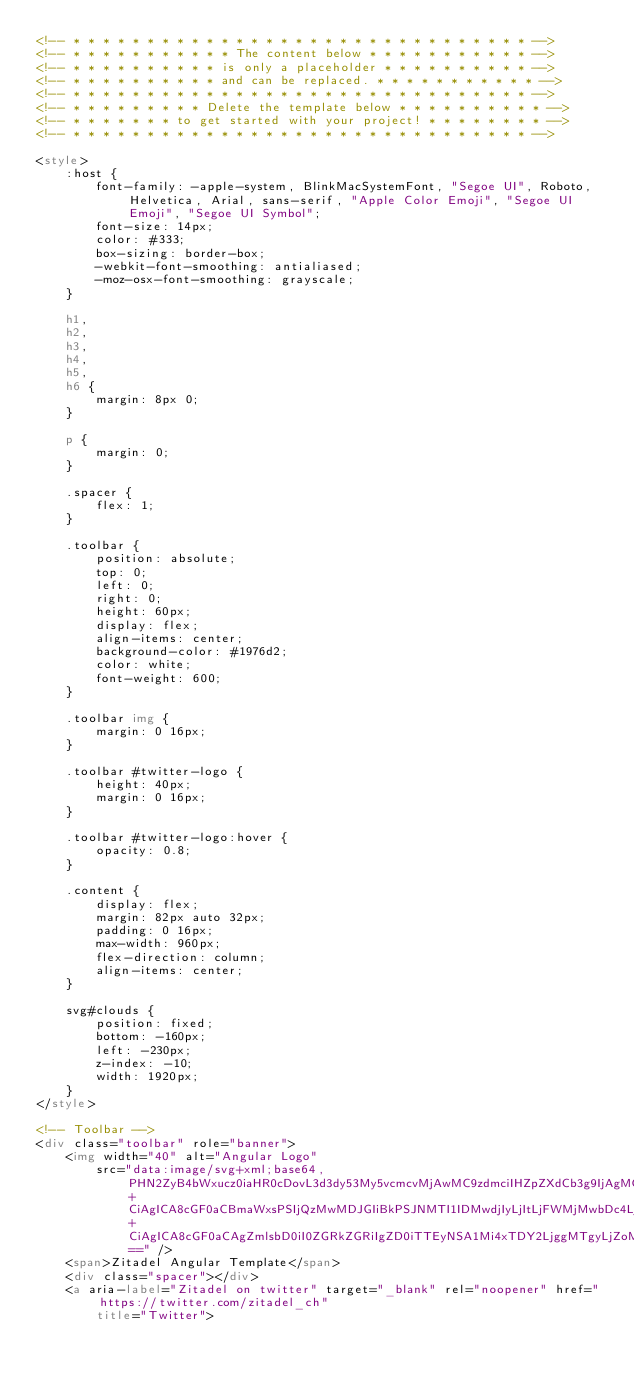<code> <loc_0><loc_0><loc_500><loc_500><_HTML_><!-- * * * * * * * * * * * * * * * * * * * * * * * * * * * * * * * -->
<!-- * * * * * * * * * * * The content below * * * * * * * * * * * -->
<!-- * * * * * * * * * * is only a placeholder * * * * * * * * * * -->
<!-- * * * * * * * * * * and can be replaced. * * * * * * * * * * * -->
<!-- * * * * * * * * * * * * * * * * * * * * * * * * * * * * * * * -->
<!-- * * * * * * * * * Delete the template below * * * * * * * * * * -->
<!-- * * * * * * * to get started with your project! * * * * * * * * -->
<!-- * * * * * * * * * * * * * * * * * * * * * * * * * * * * * * * -->

<style>
    :host {
        font-family: -apple-system, BlinkMacSystemFont, "Segoe UI", Roboto, Helvetica, Arial, sans-serif, "Apple Color Emoji", "Segoe UI Emoji", "Segoe UI Symbol";
        font-size: 14px;
        color: #333;
        box-sizing: border-box;
        -webkit-font-smoothing: antialiased;
        -moz-osx-font-smoothing: grayscale;
    }

    h1,
    h2,
    h3,
    h4,
    h5,
    h6 {
        margin: 8px 0;
    }

    p {
        margin: 0;
    }

    .spacer {
        flex: 1;
    }

    .toolbar {
        position: absolute;
        top: 0;
        left: 0;
        right: 0;
        height: 60px;
        display: flex;
        align-items: center;
        background-color: #1976d2;
        color: white;
        font-weight: 600;
    }

    .toolbar img {
        margin: 0 16px;
    }

    .toolbar #twitter-logo {
        height: 40px;
        margin: 0 16px;
    }

    .toolbar #twitter-logo:hover {
        opacity: 0.8;
    }

    .content {
        display: flex;
        margin: 82px auto 32px;
        padding: 0 16px;
        max-width: 960px;
        flex-direction: column;
        align-items: center;
    }

    svg#clouds {
        position: fixed;
        bottom: -160px;
        left: -230px;
        z-index: -10;
        width: 1920px;
    }
</style>

<!-- Toolbar -->
<div class="toolbar" role="banner">
    <img width="40" alt="Angular Logo"
        src="data:image/svg+xml;base64,PHN2ZyB4bWxucz0iaHR0cDovL3d3dy53My5vcmcvMjAwMC9zdmciIHZpZXdCb3g9IjAgMCAyNTAgMjUwIj4KICAgIDxwYXRoIGZpbGw9IiNERDAwMzEiIGQ9Ik0xMjUgMzBMMzEuOSA2My4ybDE0LjIgMTIzLjFMMTI1IDIzMGw3OC45LTQzLjcgMTQuMi0xMjMuMXoiIC8+CiAgICA8cGF0aCBmaWxsPSIjQzMwMDJGIiBkPSJNMTI1IDMwdjIyLjItLjFWMjMwbDc4LjktNDMuNyAxNC4yLTEyMy4xTDEyNSAzMHoiIC8+CiAgICA8cGF0aCAgZmlsbD0iI0ZGRkZGRiIgZD0iTTEyNSA1Mi4xTDY2LjggMTgyLjZoMjEuN2wxMS43LTI5LjJoNDkuNGwxMS43IDI5LjJIMTgzTDEyNSA1Mi4xem0xNyA4My4zaC0zNGwxNy00MC45IDE3IDQwLjl6IiAvPgogIDwvc3ZnPg==" />
    <span>Zitadel Angular Template</span>
    <div class="spacer"></div>
    <a aria-label="Zitadel on twitter" target="_blank" rel="noopener" href="https://twitter.com/zitadel_ch"
        title="Twitter"></code> 